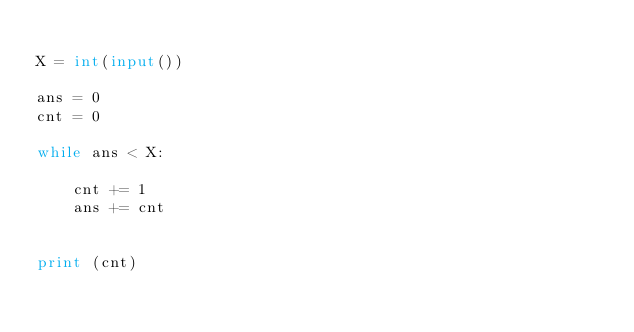Convert code to text. <code><loc_0><loc_0><loc_500><loc_500><_Python_>
X = int(input())

ans = 0
cnt = 0

while ans < X:
    
    cnt += 1
    ans += cnt


print (cnt)</code> 